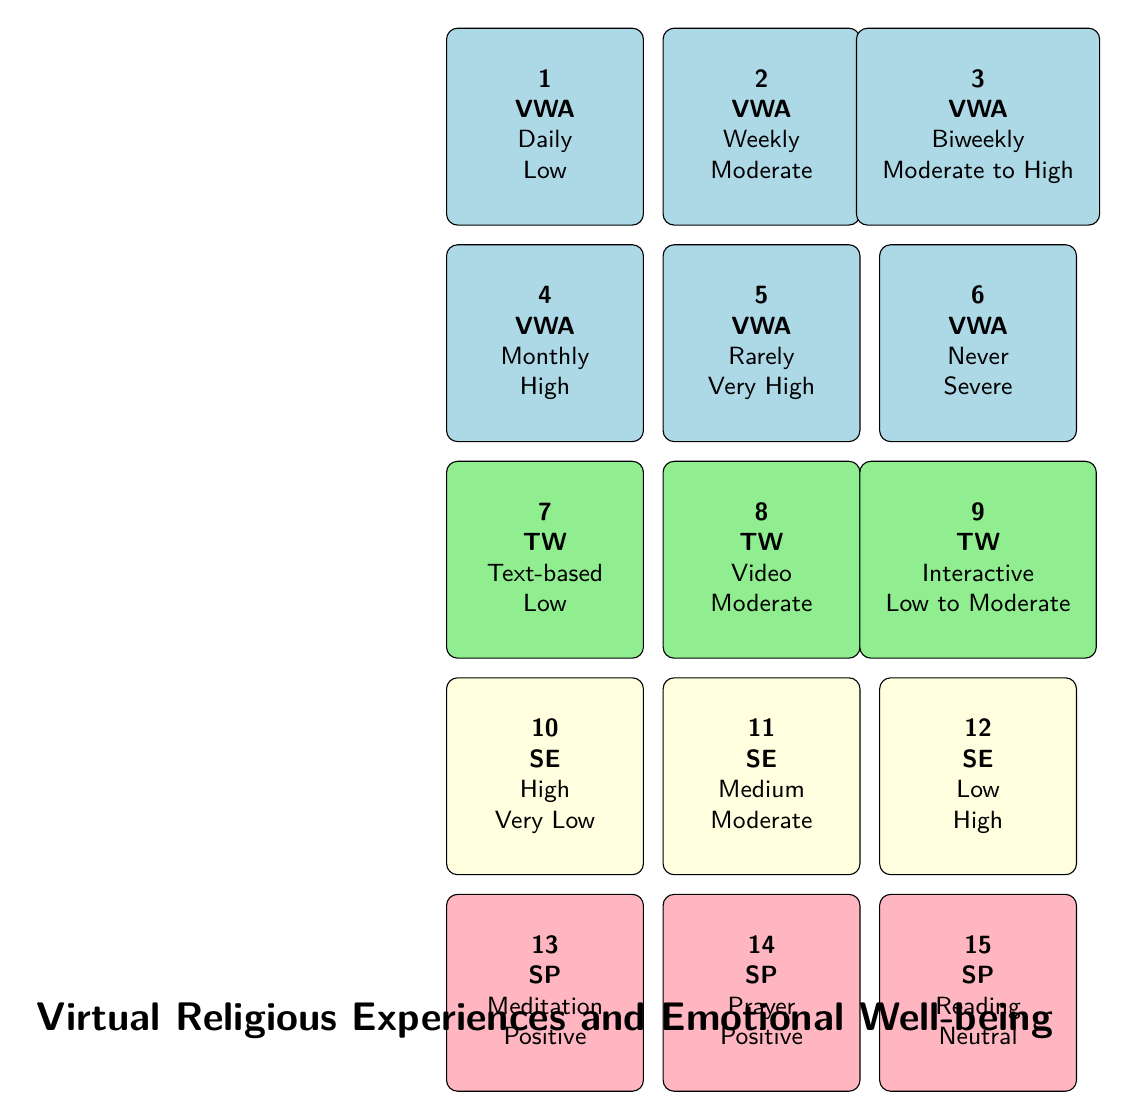What is the depression level associated with daily virtual worship attendance? From the first row of the table, we can see that the frequency of daily virtual worship attendance corresponds to a depression level categorized as "Low."
Answer: Low What frequency of virtual worship attendance corresponds to a moderate depression level? By looking through the rows for depression levels, we find that both "Weekly" and "Biweekly" have moderate to high categories. However, weekly specifically states "Moderate".
Answer: Weekly Is there a type of worship that has a depression impact classified as low? Referring to the types of worship in the table, the "Text-based service" has a depression impact categorized as "Low."
Answer: Yes What is the depression level for those who attend virtual worship monthly? The table clearly states that the frequency of attending virtual worship "Monthly" is associated with a "High" depression level.
Answer: High Which group has the least severe depression level according to the data? We analyze the various frequency categories and find that "Daily" virtual worship attendance correlates with the least severe depression level, described as "Low," while "Never" is categorized as "Severe," indicating a higher severity.
Answer: Daily What is the difference in depression levels between those who attend worship rarely and never? The data shows that "Rarely" has a depression level of "Very High," while "Never" has "Severe." Therefore, the difference in categorization is between "Very High" and "Severe." While "Severe" is a higher severity, it's important to quantify this level. Given that "Very High" indicates a greater likelihood of mental distress, we can view "Severe" as worse.
Answer: Rarely has a higher depression level than Never What is the average depression level for participants who engage in high social engagement? In the table, those with "High" social engagement have a depression level of "Very Low." There are no other participants at that engagement level listed, thus the average remains the same for that specific engagement tier.
Answer: Very Low Is prayer considered to have a positive effect on depression according to the data? The table lists "Prayer" under spiritual practices alongside its depression effect we observe is "Positive." This confirms that prayer is indeed seen as beneficial for depression levels.
Answer: Yes How do depression levels compare across different virtual worship attendance frequencies? By examining the data points, we see a gradient: daily attendance correlates with low levels while rarely and never have high and severe levels, respectively. This indicates higher attendance frequencies generally link to lower depression levels.
Answer: Higher attendance correlates with lower depression levels 